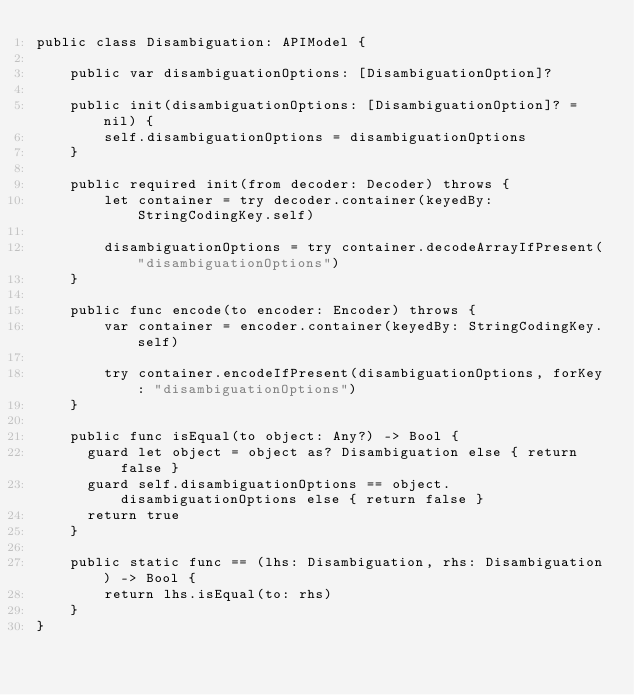<code> <loc_0><loc_0><loc_500><loc_500><_Swift_>public class Disambiguation: APIModel {

    public var disambiguationOptions: [DisambiguationOption]?

    public init(disambiguationOptions: [DisambiguationOption]? = nil) {
        self.disambiguationOptions = disambiguationOptions
    }

    public required init(from decoder: Decoder) throws {
        let container = try decoder.container(keyedBy: StringCodingKey.self)

        disambiguationOptions = try container.decodeArrayIfPresent("disambiguationOptions")
    }

    public func encode(to encoder: Encoder) throws {
        var container = encoder.container(keyedBy: StringCodingKey.self)

        try container.encodeIfPresent(disambiguationOptions, forKey: "disambiguationOptions")
    }

    public func isEqual(to object: Any?) -> Bool {
      guard let object = object as? Disambiguation else { return false }
      guard self.disambiguationOptions == object.disambiguationOptions else { return false }
      return true
    }

    public static func == (lhs: Disambiguation, rhs: Disambiguation) -> Bool {
        return lhs.isEqual(to: rhs)
    }
}
</code> 